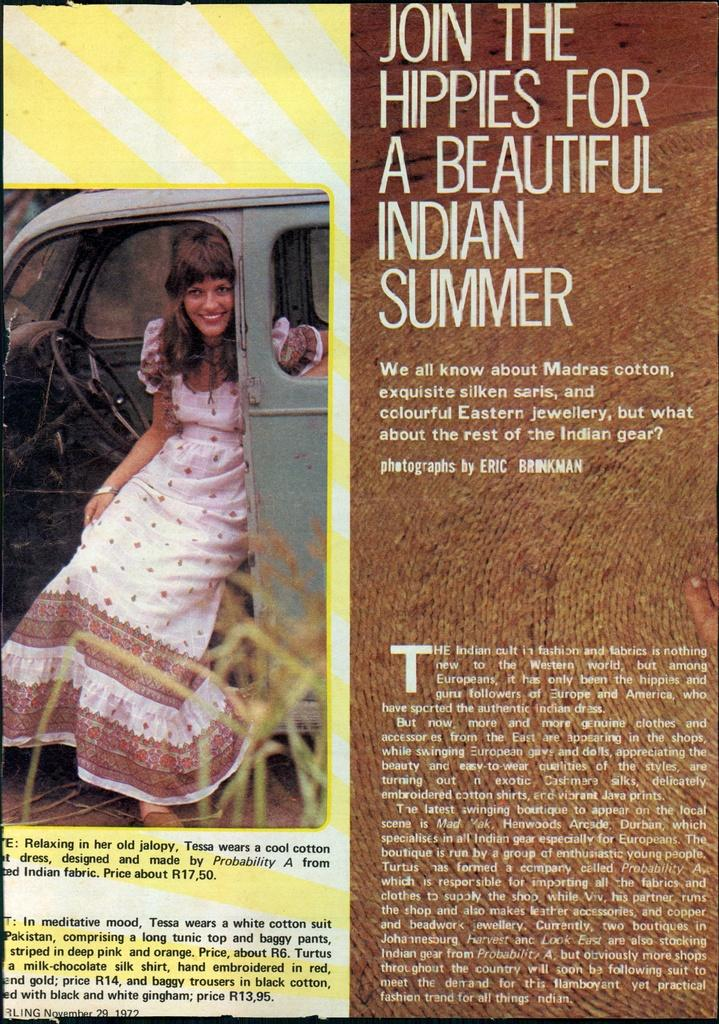What is featured on the poster in the image? There is a poster in the image, and it contains an image of a woman. What is the woman doing in the image on the poster? The woman is sitting inside a car in the image on the poster. What is the woman's expression in the image on the poster? The woman is smiling in the image on the poster. Where is the text located on the poster? The text is on the right side of the poster. What time of day is depicted in the prose on the poster? There is no prose present on the poster; it contains an image of a woman and text. How many rolls can be seen in the image? There are no rolls visible in the image. 